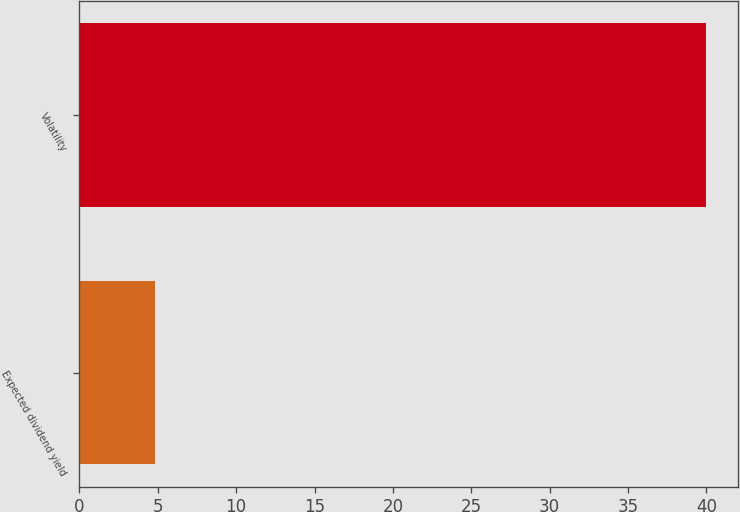Convert chart. <chart><loc_0><loc_0><loc_500><loc_500><bar_chart><fcel>Expected dividend yield<fcel>Volatility<nl><fcel>4.8<fcel>40<nl></chart> 